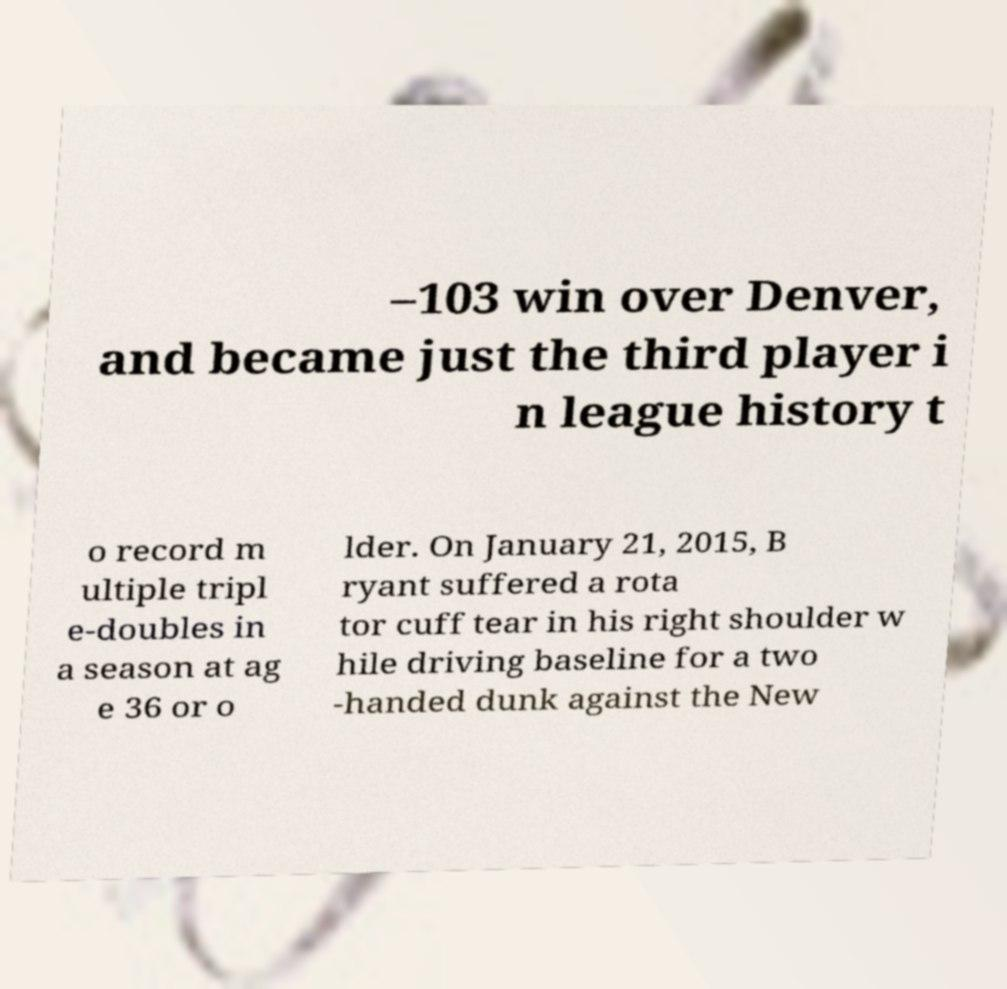Could you assist in decoding the text presented in this image and type it out clearly? –103 win over Denver, and became just the third player i n league history t o record m ultiple tripl e-doubles in a season at ag e 36 or o lder. On January 21, 2015, B ryant suffered a rota tor cuff tear in his right shoulder w hile driving baseline for a two -handed dunk against the New 